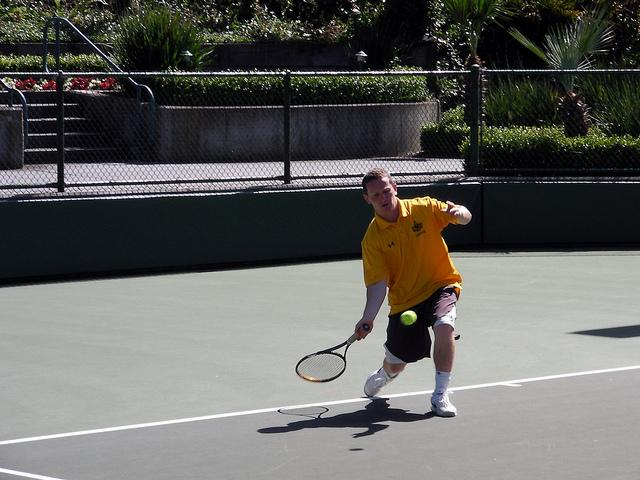What is the man attempting to do with the ball? Please explain your reasoning. hit it. The man wants to get a hit on the ball. 